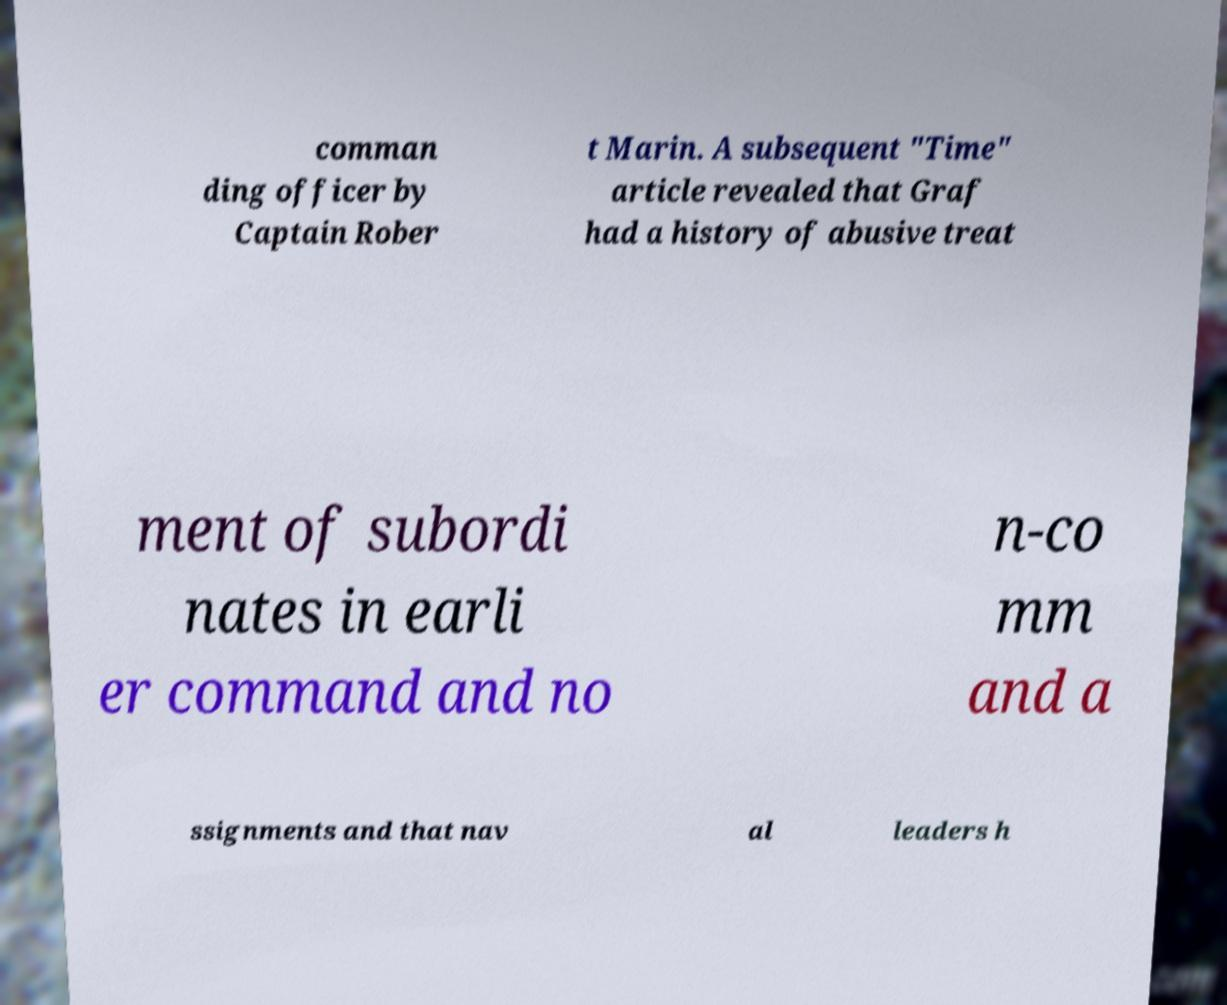Could you assist in decoding the text presented in this image and type it out clearly? comman ding officer by Captain Rober t Marin. A subsequent "Time" article revealed that Graf had a history of abusive treat ment of subordi nates in earli er command and no n-co mm and a ssignments and that nav al leaders h 